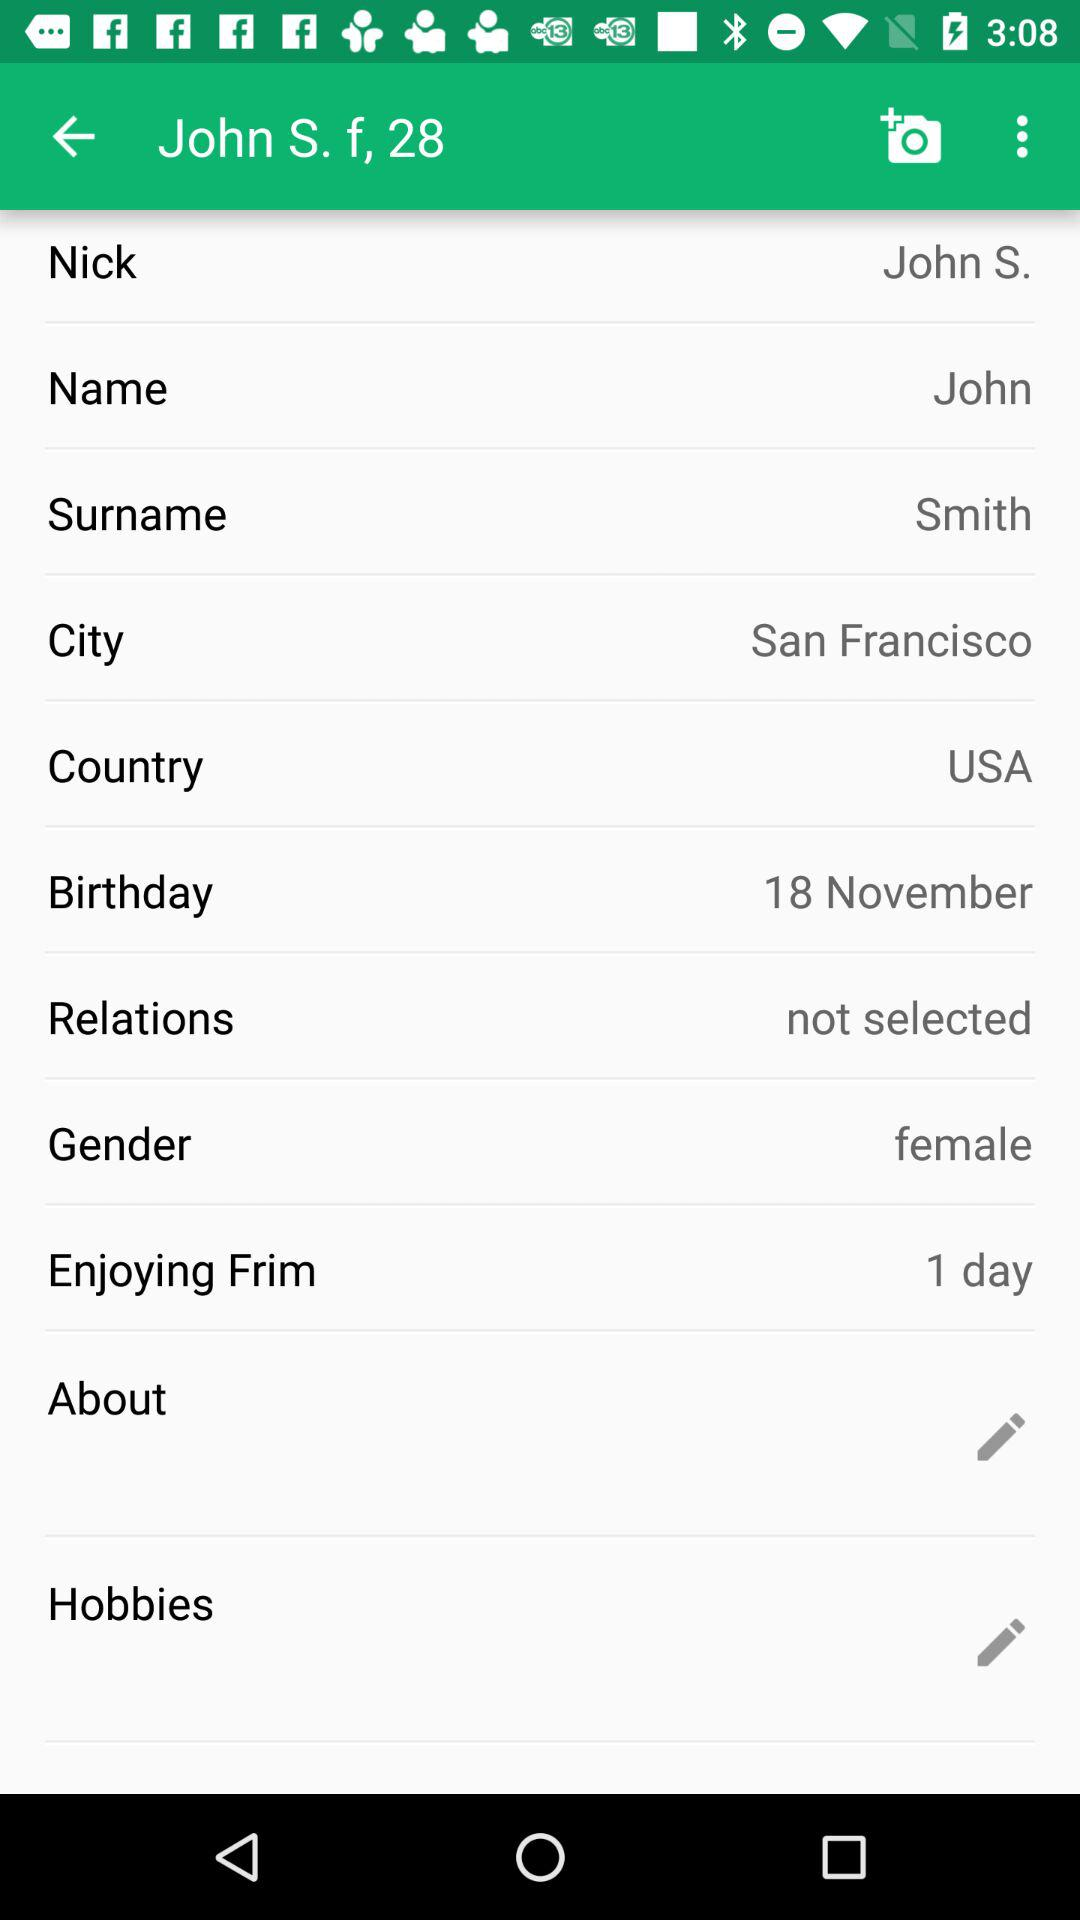What is the given surname? The given surname is Smith. 